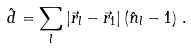<formula> <loc_0><loc_0><loc_500><loc_500>\hat { d } = \sum _ { l } | \vec { r } _ { l } - \vec { r } _ { 1 } | \left ( \hat { n } _ { l } - 1 \right ) \, .</formula> 